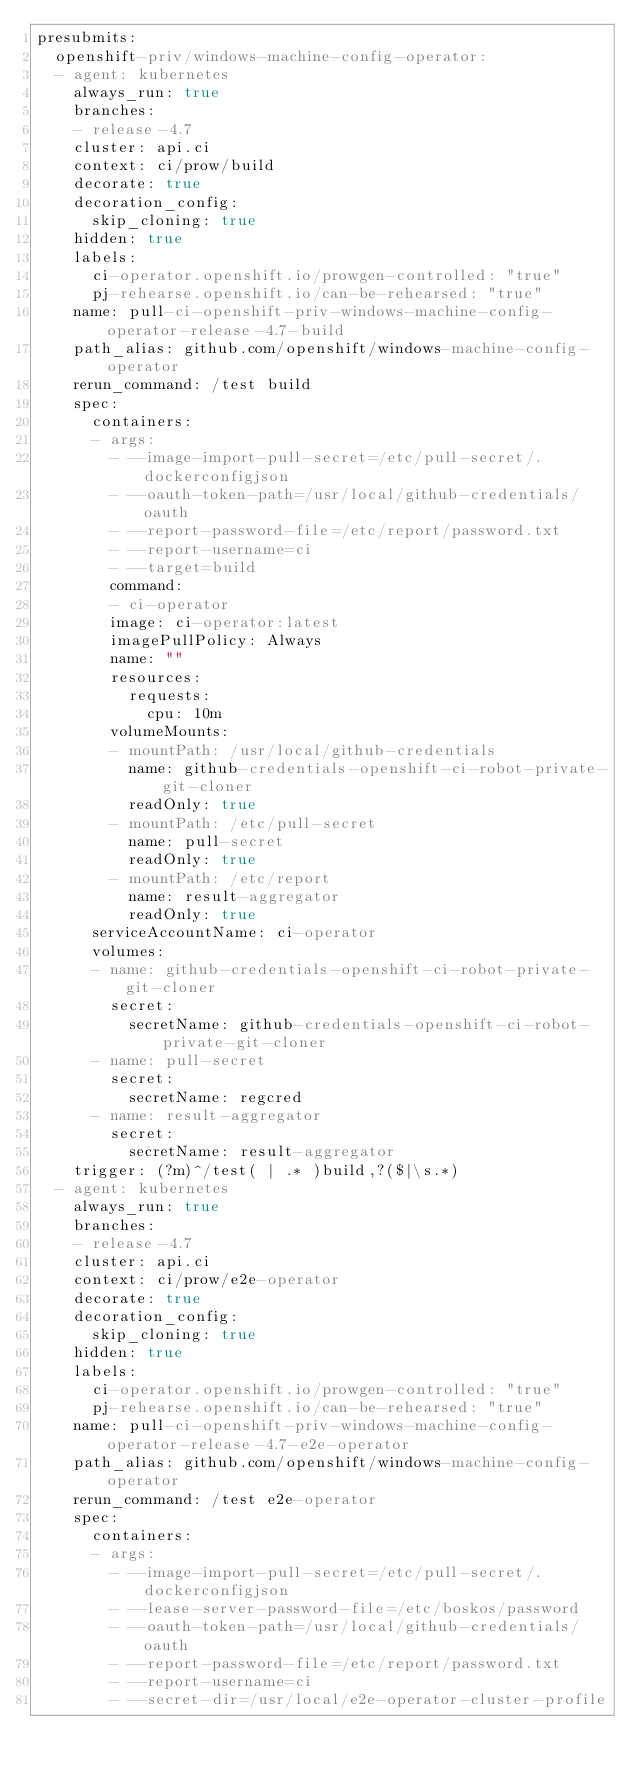<code> <loc_0><loc_0><loc_500><loc_500><_YAML_>presubmits:
  openshift-priv/windows-machine-config-operator:
  - agent: kubernetes
    always_run: true
    branches:
    - release-4.7
    cluster: api.ci
    context: ci/prow/build
    decorate: true
    decoration_config:
      skip_cloning: true
    hidden: true
    labels:
      ci-operator.openshift.io/prowgen-controlled: "true"
      pj-rehearse.openshift.io/can-be-rehearsed: "true"
    name: pull-ci-openshift-priv-windows-machine-config-operator-release-4.7-build
    path_alias: github.com/openshift/windows-machine-config-operator
    rerun_command: /test build
    spec:
      containers:
      - args:
        - --image-import-pull-secret=/etc/pull-secret/.dockerconfigjson
        - --oauth-token-path=/usr/local/github-credentials/oauth
        - --report-password-file=/etc/report/password.txt
        - --report-username=ci
        - --target=build
        command:
        - ci-operator
        image: ci-operator:latest
        imagePullPolicy: Always
        name: ""
        resources:
          requests:
            cpu: 10m
        volumeMounts:
        - mountPath: /usr/local/github-credentials
          name: github-credentials-openshift-ci-robot-private-git-cloner
          readOnly: true
        - mountPath: /etc/pull-secret
          name: pull-secret
          readOnly: true
        - mountPath: /etc/report
          name: result-aggregator
          readOnly: true
      serviceAccountName: ci-operator
      volumes:
      - name: github-credentials-openshift-ci-robot-private-git-cloner
        secret:
          secretName: github-credentials-openshift-ci-robot-private-git-cloner
      - name: pull-secret
        secret:
          secretName: regcred
      - name: result-aggregator
        secret:
          secretName: result-aggregator
    trigger: (?m)^/test( | .* )build,?($|\s.*)
  - agent: kubernetes
    always_run: true
    branches:
    - release-4.7
    cluster: api.ci
    context: ci/prow/e2e-operator
    decorate: true
    decoration_config:
      skip_cloning: true
    hidden: true
    labels:
      ci-operator.openshift.io/prowgen-controlled: "true"
      pj-rehearse.openshift.io/can-be-rehearsed: "true"
    name: pull-ci-openshift-priv-windows-machine-config-operator-release-4.7-e2e-operator
    path_alias: github.com/openshift/windows-machine-config-operator
    rerun_command: /test e2e-operator
    spec:
      containers:
      - args:
        - --image-import-pull-secret=/etc/pull-secret/.dockerconfigjson
        - --lease-server-password-file=/etc/boskos/password
        - --oauth-token-path=/usr/local/github-credentials/oauth
        - --report-password-file=/etc/report/password.txt
        - --report-username=ci
        - --secret-dir=/usr/local/e2e-operator-cluster-profile</code> 